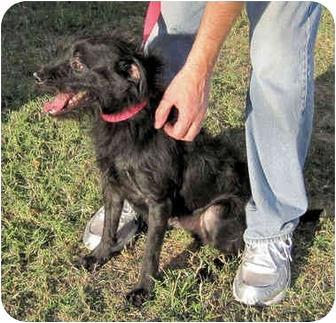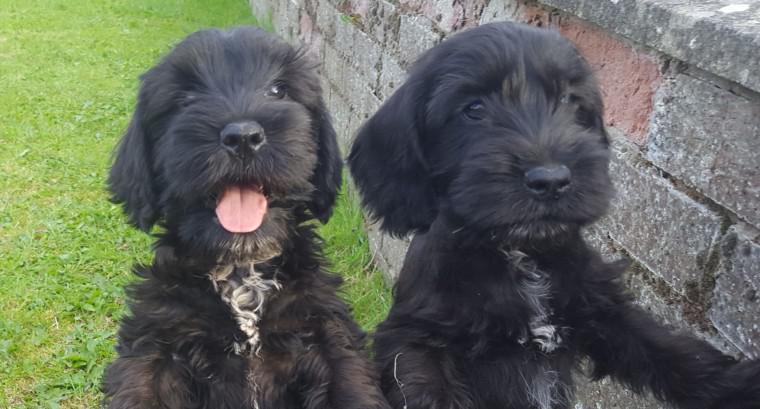The first image is the image on the left, the second image is the image on the right. For the images displayed, is the sentence "Two black puppies are side-by-side and turned forward in the right image." factually correct? Answer yes or no. Yes. 